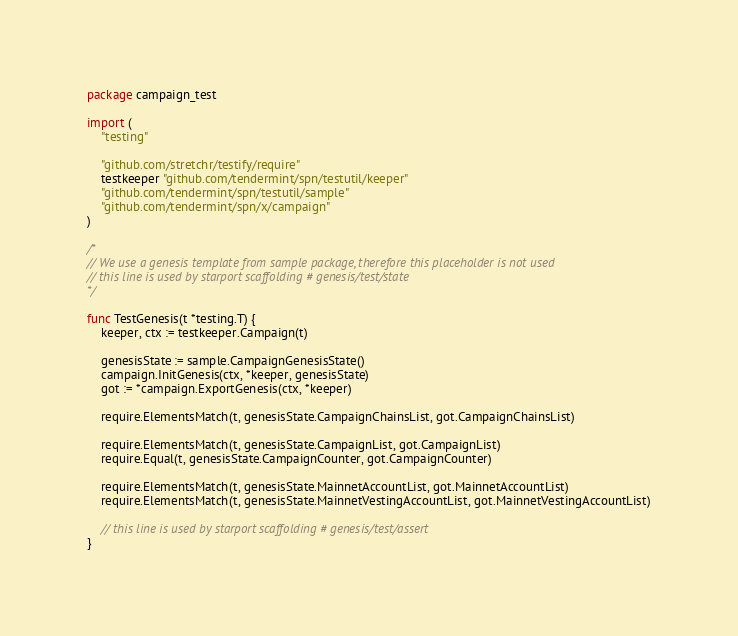<code> <loc_0><loc_0><loc_500><loc_500><_Go_>package campaign_test

import (
	"testing"

	"github.com/stretchr/testify/require"
	testkeeper "github.com/tendermint/spn/testutil/keeper"
	"github.com/tendermint/spn/testutil/sample"
	"github.com/tendermint/spn/x/campaign"
)

/*
// We use a genesis template from sample package, therefore this placeholder is not used
// this line is used by starport scaffolding # genesis/test/state
*/

func TestGenesis(t *testing.T) {
	keeper, ctx := testkeeper.Campaign(t)

	genesisState := sample.CampaignGenesisState()
	campaign.InitGenesis(ctx, *keeper, genesisState)
	got := *campaign.ExportGenesis(ctx, *keeper)

	require.ElementsMatch(t, genesisState.CampaignChainsList, got.CampaignChainsList)

	require.ElementsMatch(t, genesisState.CampaignList, got.CampaignList)
	require.Equal(t, genesisState.CampaignCounter, got.CampaignCounter)

	require.ElementsMatch(t, genesisState.MainnetAccountList, got.MainnetAccountList)
	require.ElementsMatch(t, genesisState.MainnetVestingAccountList, got.MainnetVestingAccountList)

	// this line is used by starport scaffolding # genesis/test/assert
}
</code> 